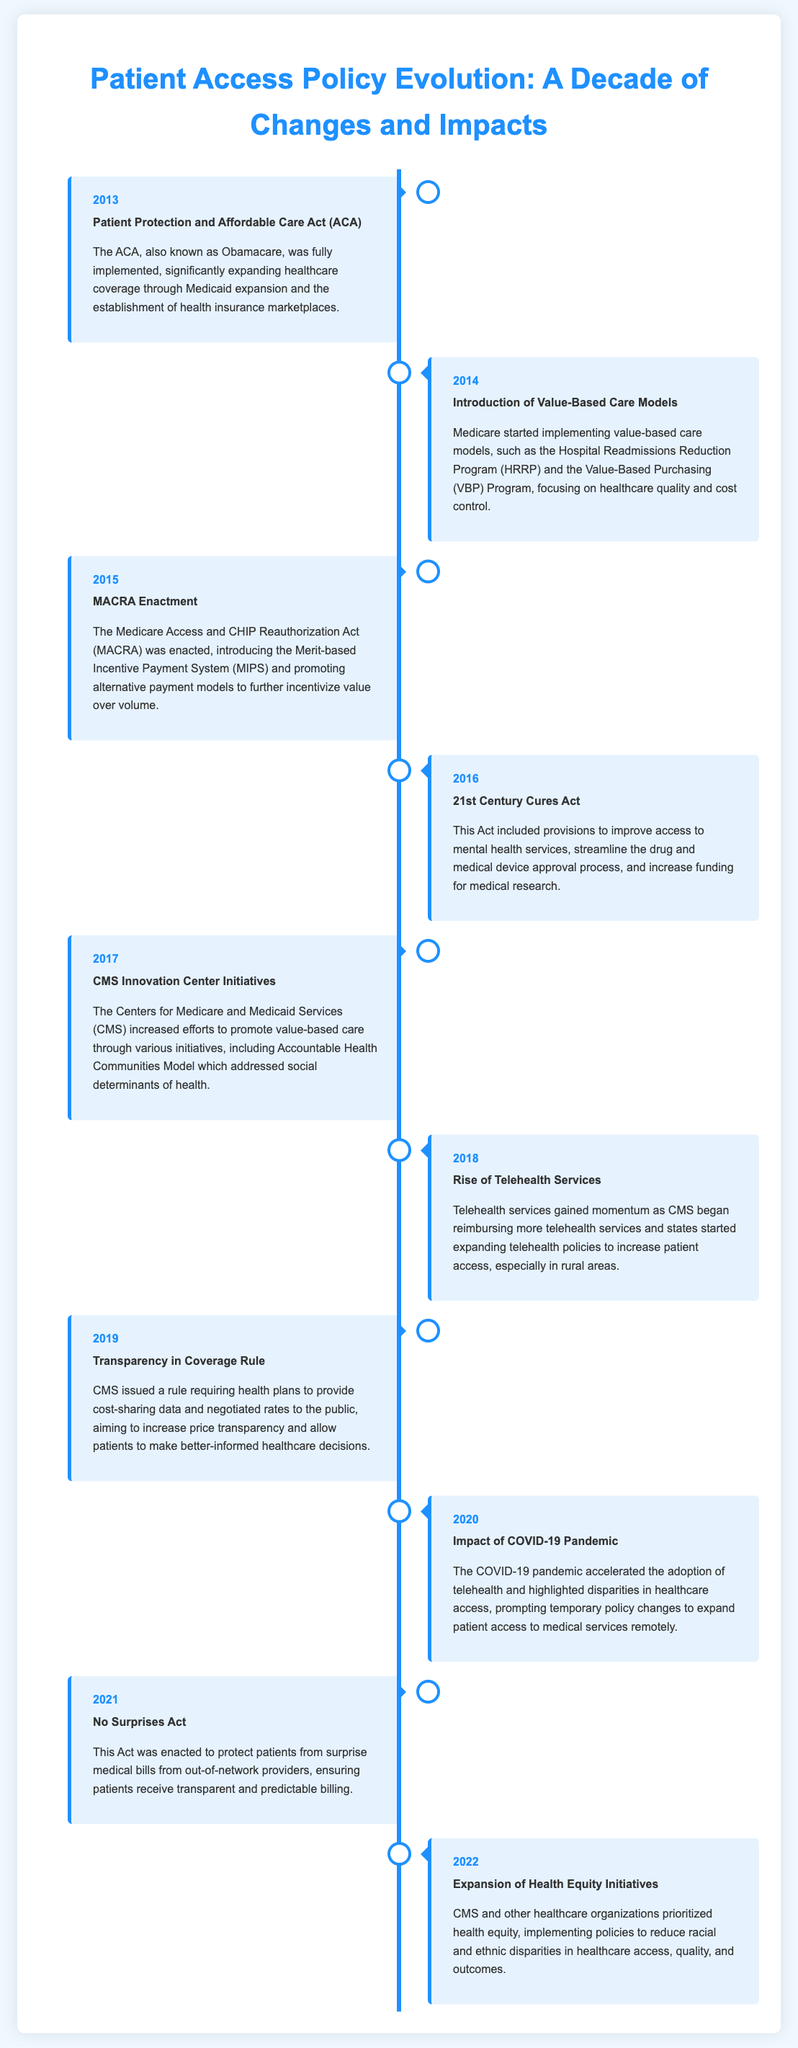what year was the Patient Protection and Affordable Care Act implemented? The ACA was fully implemented in 2013, as stated in the document.
Answer: 2013 what model did Medicare introduce in 2014? In 2014, Medicare started implementing value-based care models.
Answer: value-based care models which act was enacted in 2015? The Medicare Access and CHIP Reauthorization Act (MACRA) was enacted in 2015.
Answer: MACRA what significant act was passed in 2016? The 21st Century Cures Act included major provisions related to healthcare access.
Answer: 21st Century Cures Act what telehealth service trend began to rise in 2018? Telehealth services gained momentum, with more reimbursement and policy expansion.
Answer: Rise of Telehealth Services what was a major impact of the COVID-19 pandemic in 2020? The pandemic accelerated the adoption of telehealth services and highlighted disparities.
Answer: Accelerated telehealth adoption what does the No Surprises Act protect patients from? The Act protects patients from surprise medical bills from out-of-network providers.
Answer: Surprise medical bills what year did CMS expand health equity initiatives? Health equity initiatives were expanded in 2022.
Answer: 2022 which healthcare quality focus was emphasized by MACRA? MACRA promoted value over volume in healthcare services.
Answer: Value over volume 